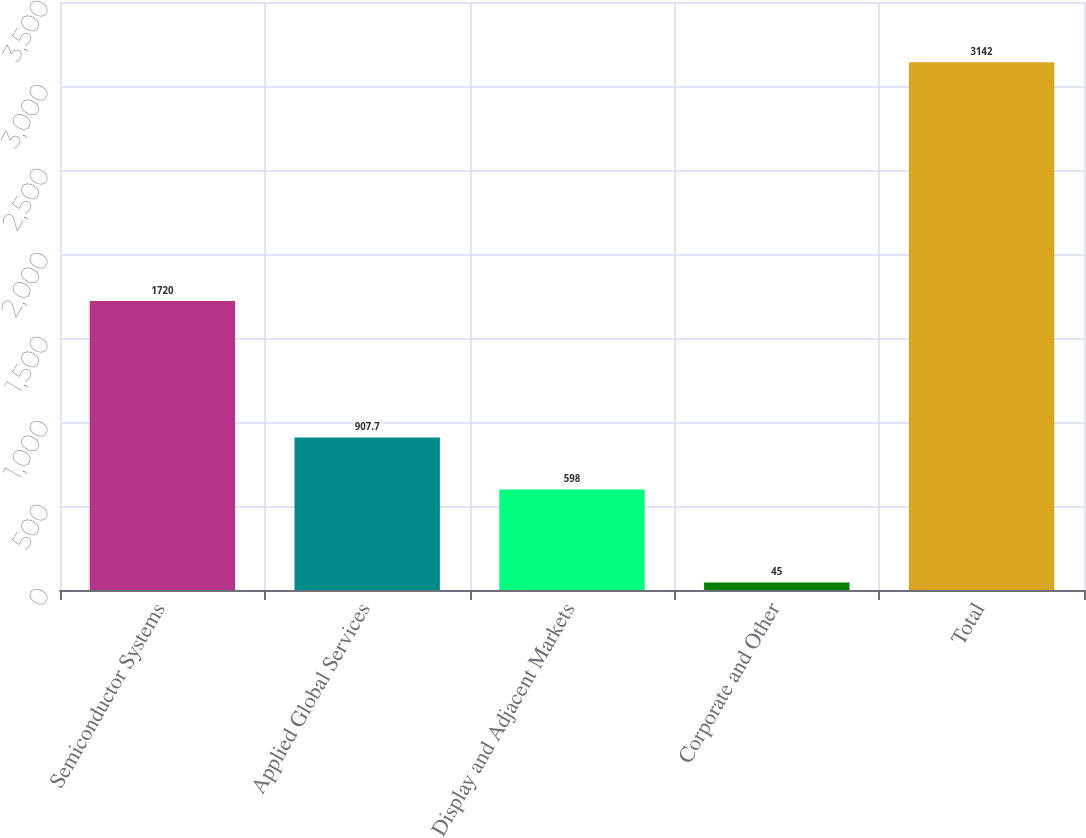Convert chart to OTSL. <chart><loc_0><loc_0><loc_500><loc_500><bar_chart><fcel>Semiconductor Systems<fcel>Applied Global Services<fcel>Display and Adjacent Markets<fcel>Corporate and Other<fcel>Total<nl><fcel>1720<fcel>907.7<fcel>598<fcel>45<fcel>3142<nl></chart> 